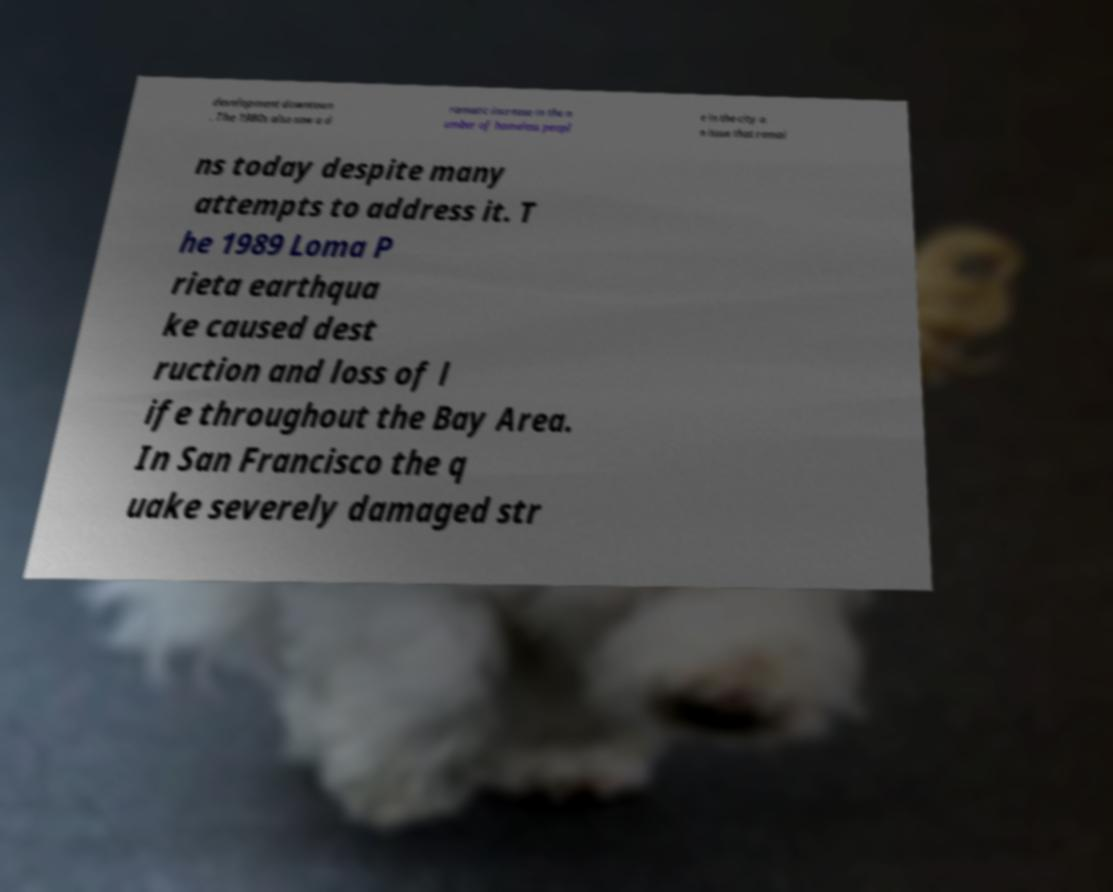Please identify and transcribe the text found in this image. development downtown . The 1980s also saw a d ramatic increase in the n umber of homeless peopl e in the city a n issue that remai ns today despite many attempts to address it. T he 1989 Loma P rieta earthqua ke caused dest ruction and loss of l ife throughout the Bay Area. In San Francisco the q uake severely damaged str 